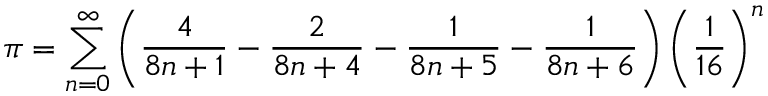Convert formula to latex. <formula><loc_0><loc_0><loc_500><loc_500>\pi = \sum _ { n = 0 } ^ { \infty } \left ( { \frac { 4 } { 8 n + 1 } } - { \frac { 2 } { 8 n + 4 } } - { \frac { 1 } { 8 n + 5 } } - { \frac { 1 } { 8 n + 6 } } \right ) \left ( { \frac { 1 } { 1 6 } } \right ) ^ { n }</formula> 